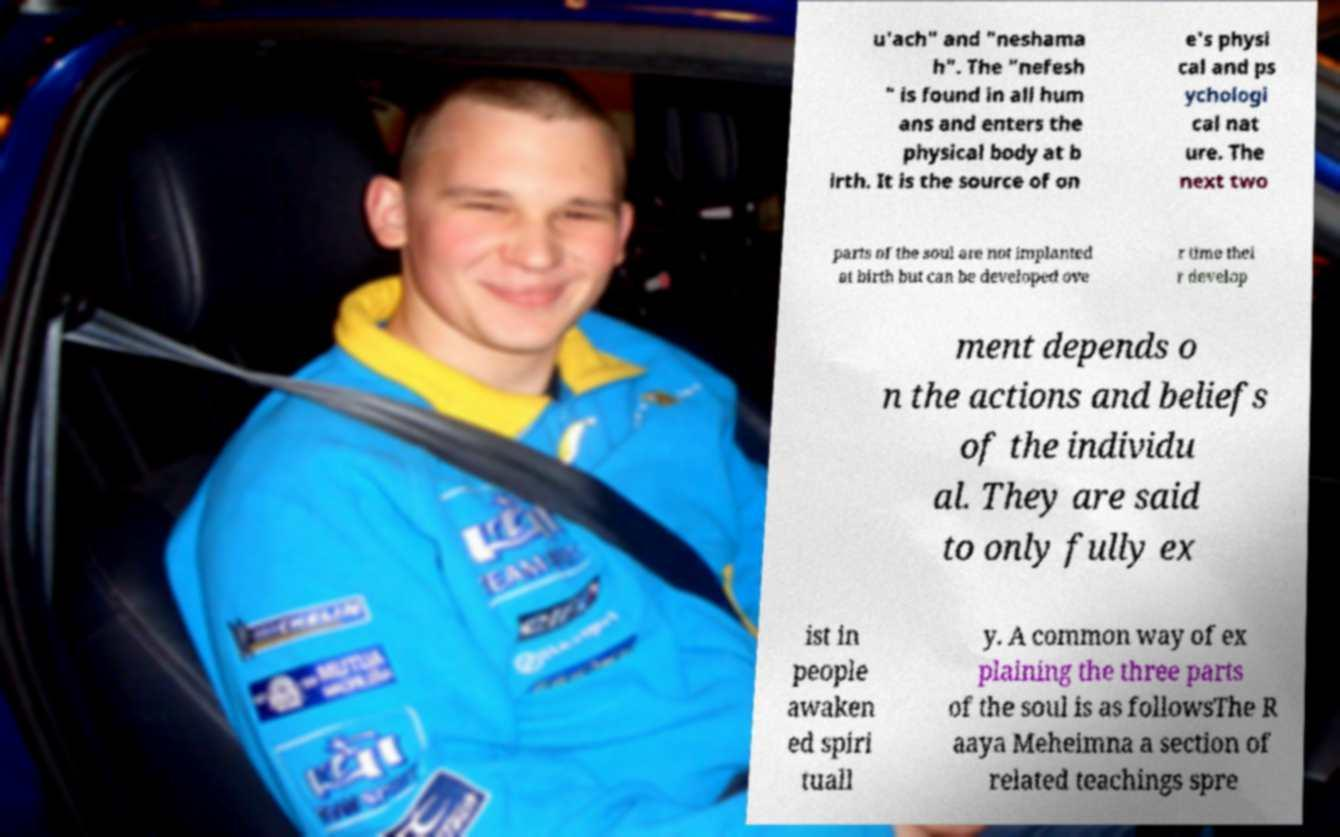Please read and relay the text visible in this image. What does it say? u'ach" and "neshama h". The "nefesh " is found in all hum ans and enters the physical body at b irth. It is the source of on e's physi cal and ps ychologi cal nat ure. The next two parts of the soul are not implanted at birth but can be developed ove r time thei r develop ment depends o n the actions and beliefs of the individu al. They are said to only fully ex ist in people awaken ed spiri tuall y. A common way of ex plaining the three parts of the soul is as followsThe R aaya Meheimna a section of related teachings spre 